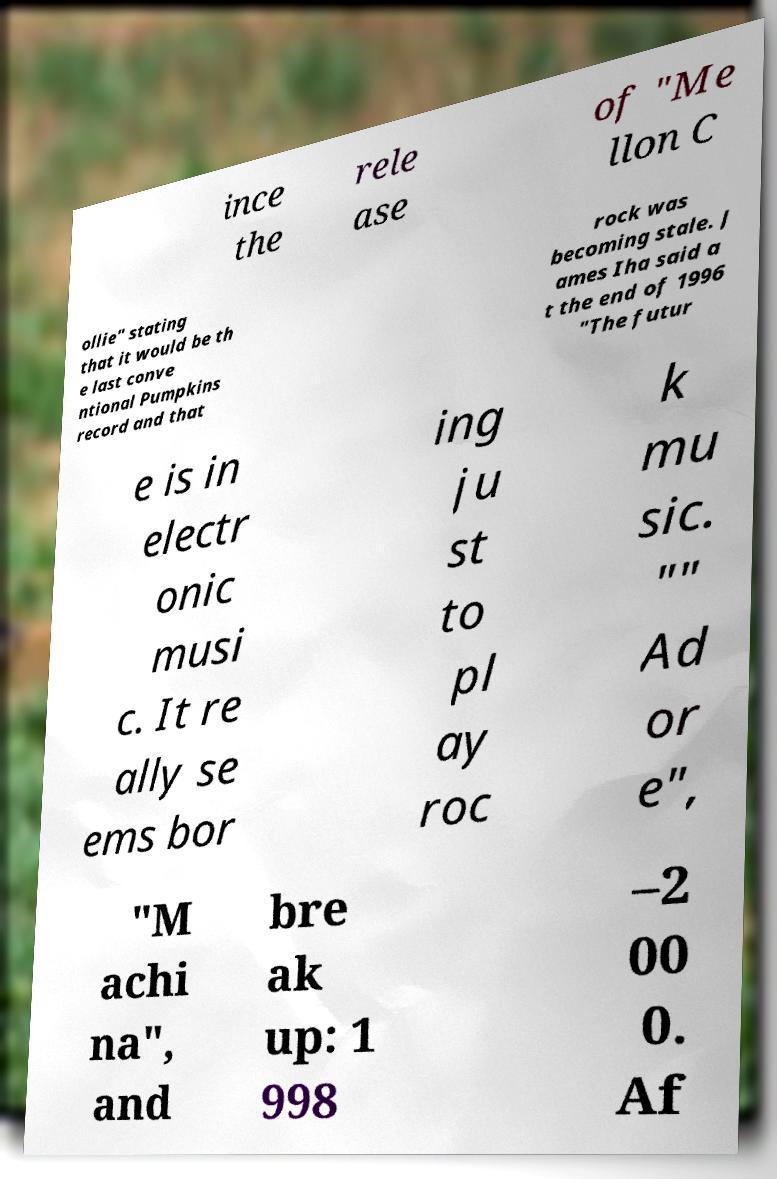What messages or text are displayed in this image? I need them in a readable, typed format. ince the rele ase of "Me llon C ollie" stating that it would be th e last conve ntional Pumpkins record and that rock was becoming stale. J ames Iha said a t the end of 1996 "The futur e is in electr onic musi c. It re ally se ems bor ing ju st to pl ay roc k mu sic. "" Ad or e", "M achi na", and bre ak up: 1 998 –2 00 0. Af 